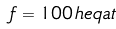Convert formula to latex. <formula><loc_0><loc_0><loc_500><loc_500>f = 1 0 0 \, h e q a t</formula> 